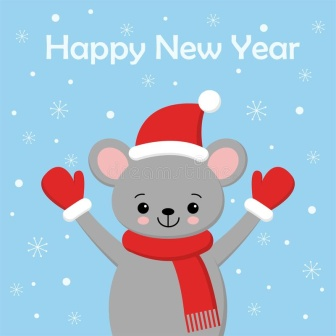What other festive activities might this mouse enjoy during this time of year? During this festive time of year, the mouse would likely engage in many joyful activities. It might spend its days ice skating on a frozen pond with friends, decorating its cozy burrow with ribbons and holly, or making warm, cheesy treats to enjoy by a crackling fire. It could also be building tiny snowmice in the yard, singing holiday songs, or exchanging gifts with other woodland creatures. The mouse might also enjoy sitting with little ones and reading festive stories, participating in holiday parades, and, of course, eagerly counting down the seconds to midnight on New Year’s Eve.  What’s the magic secret behind the mouse's joyful expression? The magic secret behind the mouse’s joyful expression lies in the spirit of togetherness and the simple pleasures of life. This mouse values the moments spent with friends and family, cherishing the joy of shared activities, laughter, and love. Its happiness comes from spreading cheer, whether through festive decorations, warm greetings, or heartfelt stories. The mouse’s delight is also rooted in its appreciation for the beauty of each season and the magic of the holidays, as these moments remind it of the wonders that life offers. In its tiny heart, the mouse believes that happiness grows when shared, and this belief is what shines through in its joyful expression. 